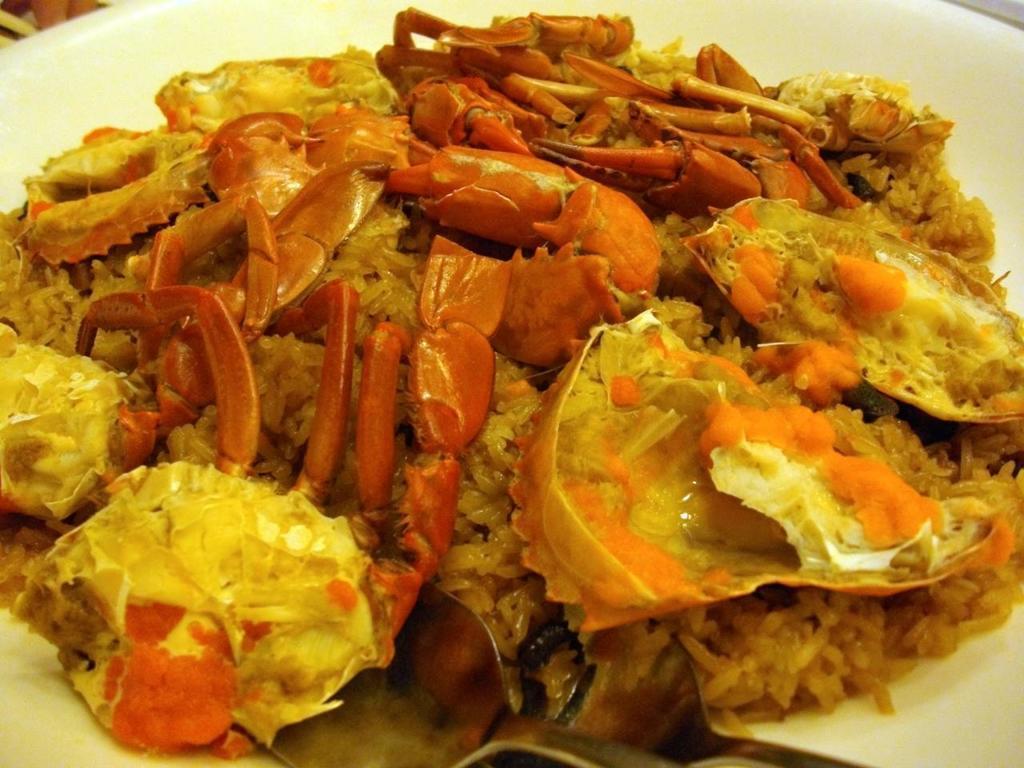Can you describe this image briefly? In this image I can see a white colour plate and on it I can see food. I can see colour of the food is brown and little bit yellow. 